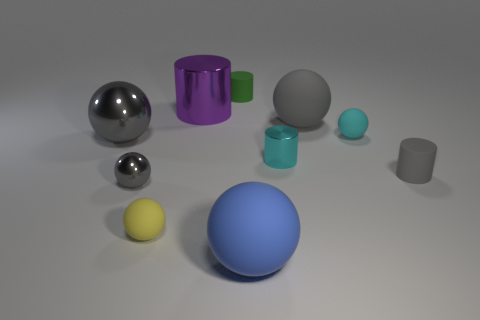Are there any other things that have the same shape as the big blue matte object?
Your answer should be compact. Yes. There is a tiny object that is both behind the large gray metal sphere and on the left side of the tiny cyan matte object; what is it made of?
Your answer should be very brief. Rubber. Do the tiny green cylinder and the large object that is to the left of the purple cylinder have the same material?
Provide a short and direct response. No. Are there any other things that have the same size as the cyan metal cylinder?
Your answer should be compact. Yes. How many things are either tiny cyan spheres or metal objects that are to the left of the green cylinder?
Make the answer very short. 4. Is the size of the cyan matte ball in front of the big cylinder the same as the gray shiny object to the left of the tiny gray metal object?
Offer a very short reply. No. How many other objects are the same color as the tiny metal sphere?
Offer a terse response. 3. There is a blue matte object; is its size the same as the gray thing to the left of the tiny gray shiny sphere?
Make the answer very short. Yes. There is a cyan cylinder on the left side of the big gray thing to the right of the green cylinder; what size is it?
Offer a terse response. Small. There is a large metal object that is the same shape as the big blue matte thing; what is its color?
Ensure brevity in your answer.  Gray. 